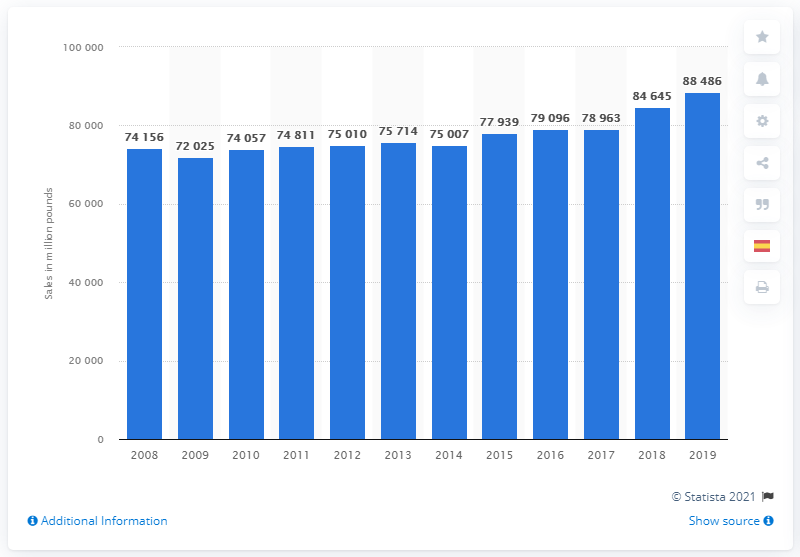Outline some significant characteristics in this image. In 2019, the amount of resin sold in the U.S. was approximately 88,486 units. 